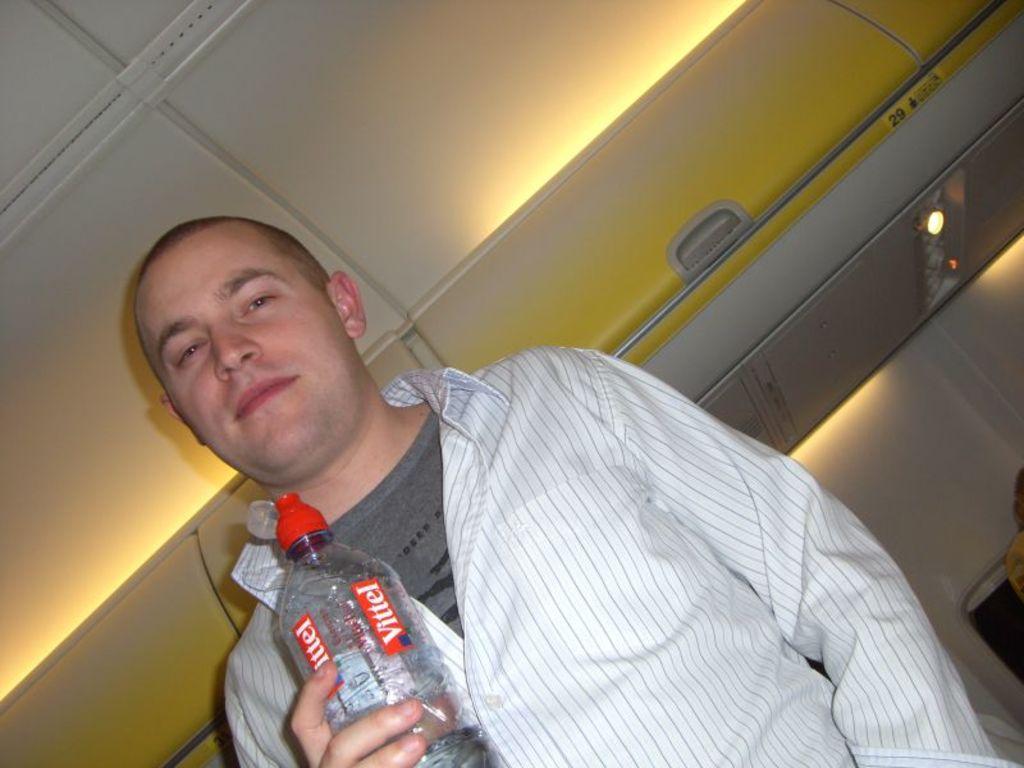Please provide a concise description of this image. In the picture a person is standing and holding the bottle. In the background there is a box or luggage carrier. The person is smiling. 